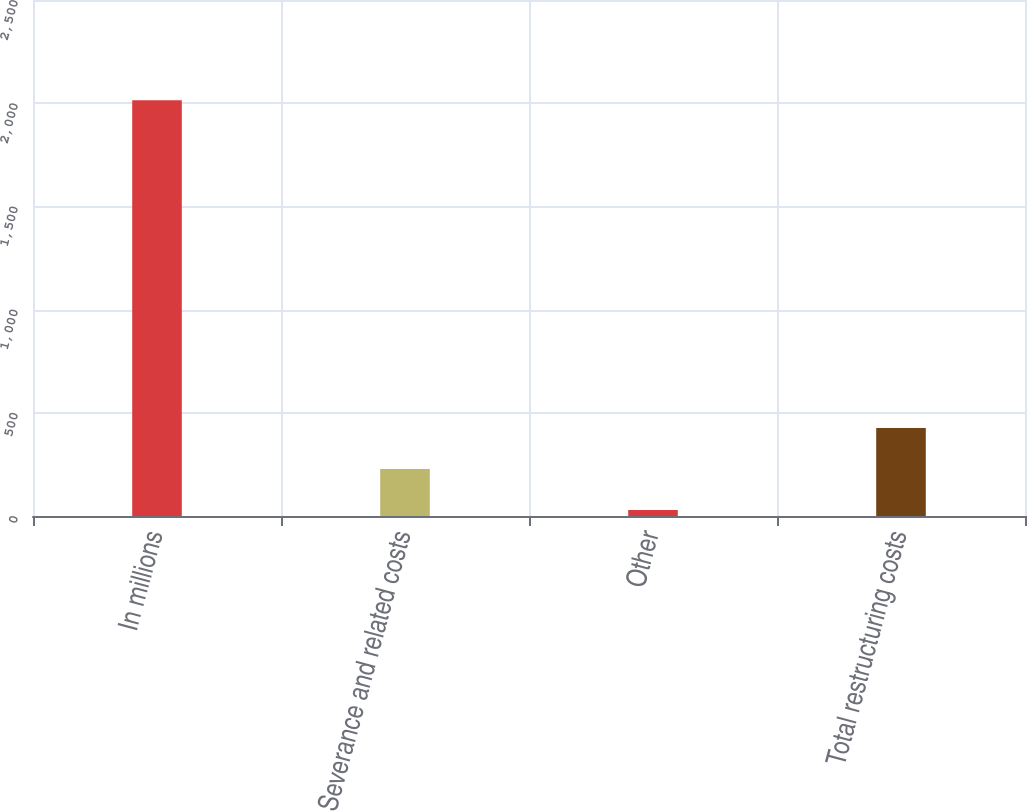Convert chart. <chart><loc_0><loc_0><loc_500><loc_500><bar_chart><fcel>In millions<fcel>Severance and related costs<fcel>Other<fcel>Total restructuring costs<nl><fcel>2014<fcel>227.86<fcel>29.4<fcel>426.32<nl></chart> 